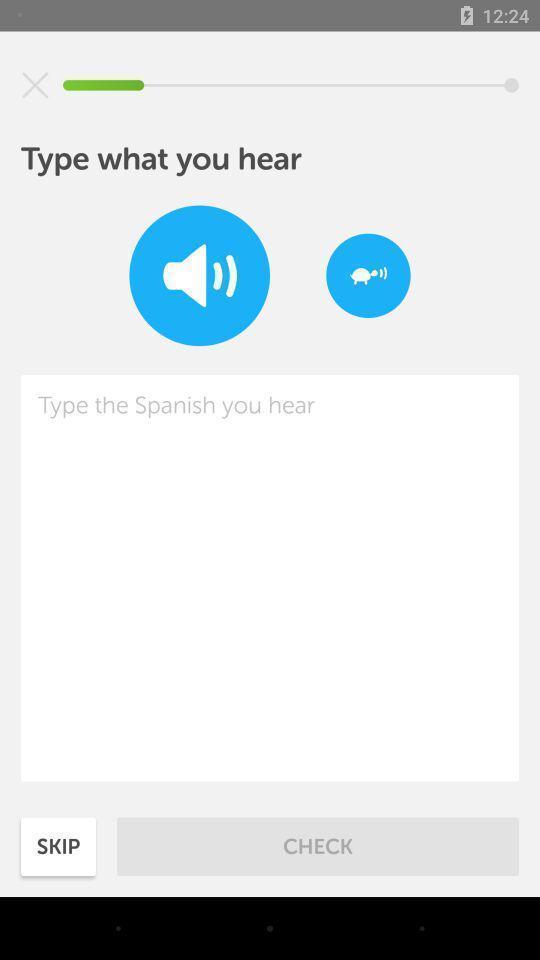Give me a summary of this screen capture. Screen displaying multiple controls. 